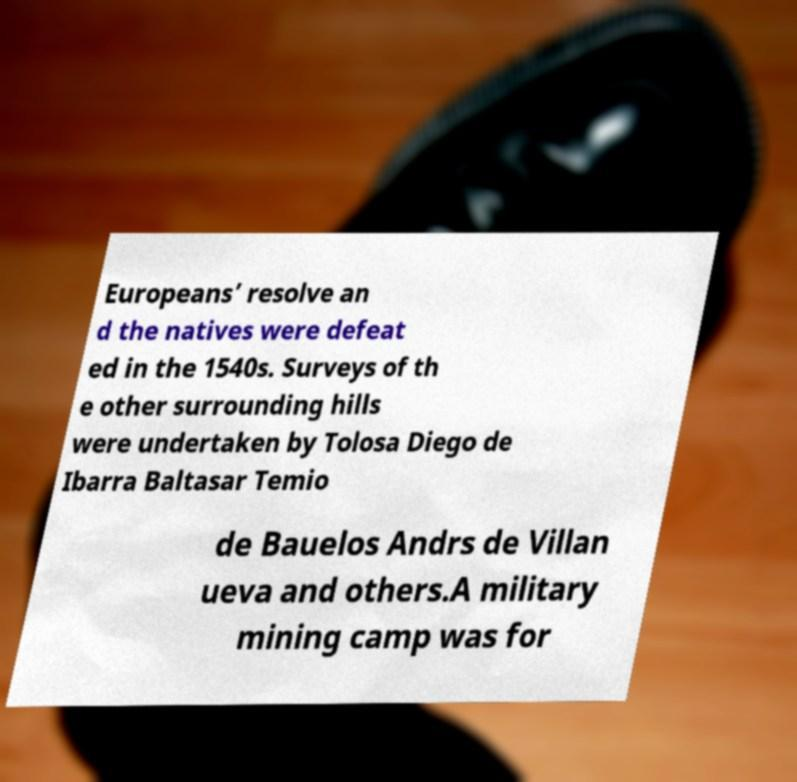Please identify and transcribe the text found in this image. Europeans’ resolve an d the natives were defeat ed in the 1540s. Surveys of th e other surrounding hills were undertaken by Tolosa Diego de Ibarra Baltasar Temio de Bauelos Andrs de Villan ueva and others.A military mining camp was for 